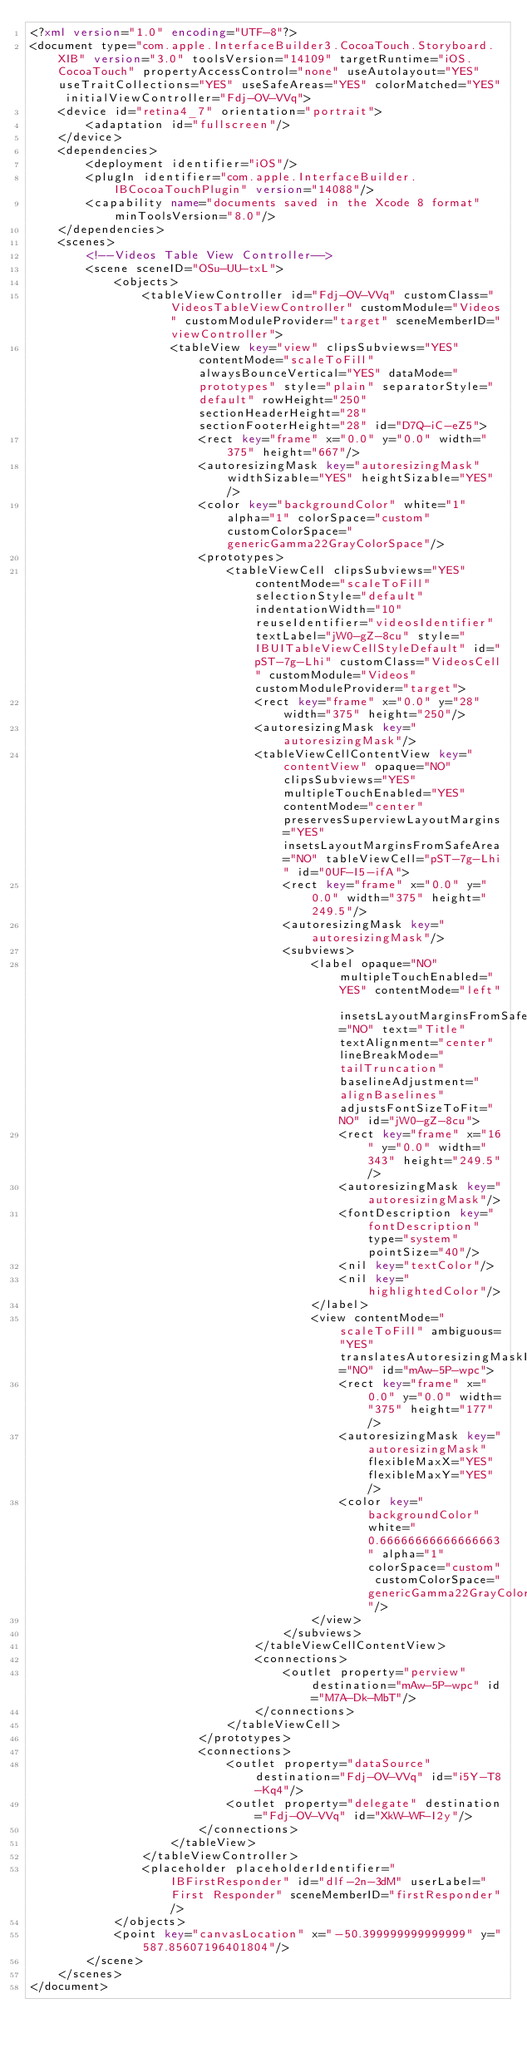<code> <loc_0><loc_0><loc_500><loc_500><_XML_><?xml version="1.0" encoding="UTF-8"?>
<document type="com.apple.InterfaceBuilder3.CocoaTouch.Storyboard.XIB" version="3.0" toolsVersion="14109" targetRuntime="iOS.CocoaTouch" propertyAccessControl="none" useAutolayout="YES" useTraitCollections="YES" useSafeAreas="YES" colorMatched="YES" initialViewController="Fdj-OV-VVq">
    <device id="retina4_7" orientation="portrait">
        <adaptation id="fullscreen"/>
    </device>
    <dependencies>
        <deployment identifier="iOS"/>
        <plugIn identifier="com.apple.InterfaceBuilder.IBCocoaTouchPlugin" version="14088"/>
        <capability name="documents saved in the Xcode 8 format" minToolsVersion="8.0"/>
    </dependencies>
    <scenes>
        <!--Videos Table View Controller-->
        <scene sceneID="OSu-UU-txL">
            <objects>
                <tableViewController id="Fdj-OV-VVq" customClass="VideosTableViewController" customModule="Videos" customModuleProvider="target" sceneMemberID="viewController">
                    <tableView key="view" clipsSubviews="YES" contentMode="scaleToFill" alwaysBounceVertical="YES" dataMode="prototypes" style="plain" separatorStyle="default" rowHeight="250" sectionHeaderHeight="28" sectionFooterHeight="28" id="D7Q-iC-eZ5">
                        <rect key="frame" x="0.0" y="0.0" width="375" height="667"/>
                        <autoresizingMask key="autoresizingMask" widthSizable="YES" heightSizable="YES"/>
                        <color key="backgroundColor" white="1" alpha="1" colorSpace="custom" customColorSpace="genericGamma22GrayColorSpace"/>
                        <prototypes>
                            <tableViewCell clipsSubviews="YES" contentMode="scaleToFill" selectionStyle="default" indentationWidth="10" reuseIdentifier="videosIdentifier" textLabel="jW0-gZ-8cu" style="IBUITableViewCellStyleDefault" id="pST-7g-Lhi" customClass="VideosCell" customModule="Videos" customModuleProvider="target">
                                <rect key="frame" x="0.0" y="28" width="375" height="250"/>
                                <autoresizingMask key="autoresizingMask"/>
                                <tableViewCellContentView key="contentView" opaque="NO" clipsSubviews="YES" multipleTouchEnabled="YES" contentMode="center" preservesSuperviewLayoutMargins="YES" insetsLayoutMarginsFromSafeArea="NO" tableViewCell="pST-7g-Lhi" id="0UF-I5-ifA">
                                    <rect key="frame" x="0.0" y="0.0" width="375" height="249.5"/>
                                    <autoresizingMask key="autoresizingMask"/>
                                    <subviews>
                                        <label opaque="NO" multipleTouchEnabled="YES" contentMode="left" insetsLayoutMarginsFromSafeArea="NO" text="Title" textAlignment="center" lineBreakMode="tailTruncation" baselineAdjustment="alignBaselines" adjustsFontSizeToFit="NO" id="jW0-gZ-8cu">
                                            <rect key="frame" x="16" y="0.0" width="343" height="249.5"/>
                                            <autoresizingMask key="autoresizingMask"/>
                                            <fontDescription key="fontDescription" type="system" pointSize="40"/>
                                            <nil key="textColor"/>
                                            <nil key="highlightedColor"/>
                                        </label>
                                        <view contentMode="scaleToFill" ambiguous="YES" translatesAutoresizingMaskIntoConstraints="NO" id="mAw-5P-wpc">
                                            <rect key="frame" x="0.0" y="0.0" width="375" height="177"/>
                                            <autoresizingMask key="autoresizingMask" flexibleMaxX="YES" flexibleMaxY="YES"/>
                                            <color key="backgroundColor" white="0.66666666666666663" alpha="1" colorSpace="custom" customColorSpace="genericGamma22GrayColorSpace"/>
                                        </view>
                                    </subviews>
                                </tableViewCellContentView>
                                <connections>
                                    <outlet property="perview" destination="mAw-5P-wpc" id="M7A-Dk-MbT"/>
                                </connections>
                            </tableViewCell>
                        </prototypes>
                        <connections>
                            <outlet property="dataSource" destination="Fdj-OV-VVq" id="i5Y-T8-Kq4"/>
                            <outlet property="delegate" destination="Fdj-OV-VVq" id="XkW-WF-I2y"/>
                        </connections>
                    </tableView>
                </tableViewController>
                <placeholder placeholderIdentifier="IBFirstResponder" id="dlf-2n-3dM" userLabel="First Responder" sceneMemberID="firstResponder"/>
            </objects>
            <point key="canvasLocation" x="-50.399999999999999" y="587.85607196401804"/>
        </scene>
    </scenes>
</document>
</code> 